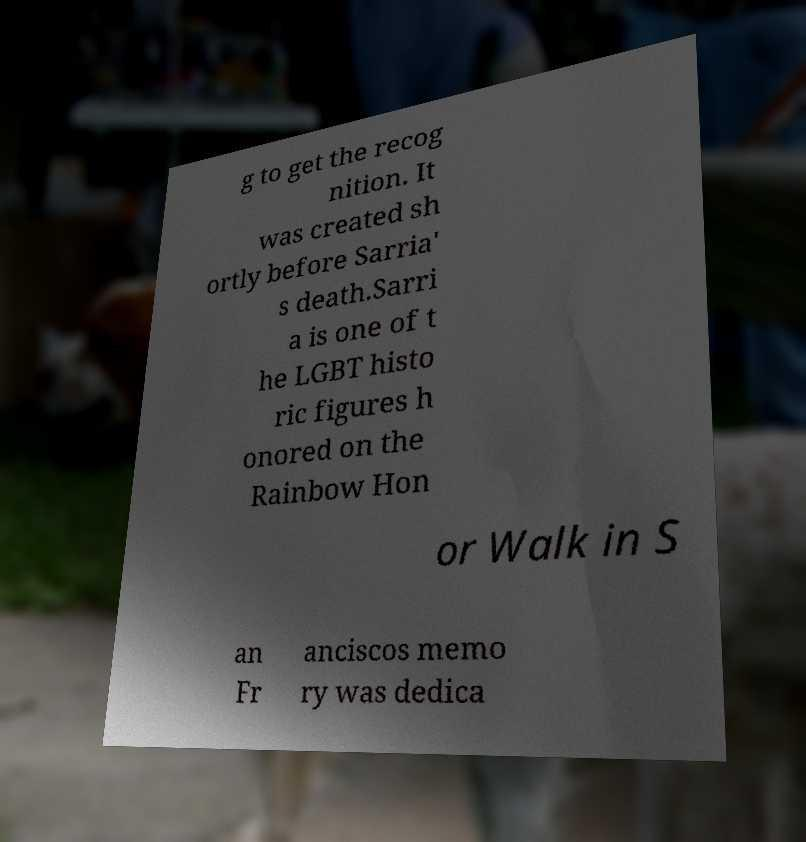Could you extract and type out the text from this image? g to get the recog nition. It was created sh ortly before Sarria' s death.Sarri a is one of t he LGBT histo ric figures h onored on the Rainbow Hon or Walk in S an Fr anciscos memo ry was dedica 